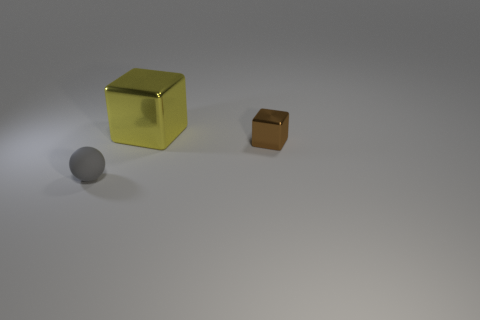There is a tiny object on the right side of the tiny object that is on the left side of the large yellow metallic object; what is its shape?
Ensure brevity in your answer.  Cube. Is there a gray object that has the same size as the brown object?
Your answer should be very brief. Yes. Are there more large cyan shiny cylinders than small gray things?
Provide a short and direct response. No. There is a object in front of the small brown metallic thing; does it have the same size as the brown object in front of the big yellow shiny thing?
Offer a very short reply. Yes. How many things are both to the right of the gray matte thing and in front of the yellow metallic object?
Give a very brief answer. 1. What is the color of the big object that is the same shape as the tiny brown object?
Offer a very short reply. Yellow. Are there fewer small gray objects than purple shiny spheres?
Ensure brevity in your answer.  No. There is a ball; does it have the same size as the block in front of the big shiny object?
Give a very brief answer. Yes. What is the color of the shiny object that is behind the cube that is right of the yellow object?
Make the answer very short. Yellow. What number of things are small objects behind the tiny gray object or things that are left of the small metallic object?
Your answer should be very brief. 3. 